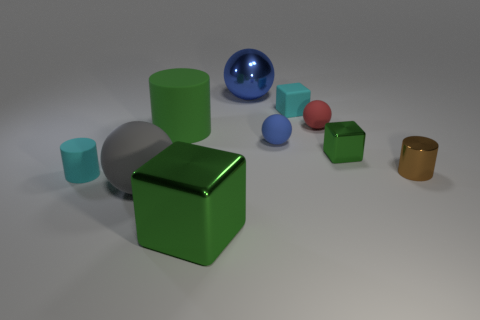What is the shape of the large metallic thing that is the same color as the big cylinder?
Provide a short and direct response. Cube. What size is the thing that is the same color as the tiny rubber block?
Offer a terse response. Small. Is there any other thing that has the same material as the tiny brown thing?
Keep it short and to the point. Yes. What is the shape of the tiny red thing?
Your answer should be compact. Sphere. What is the shape of the cyan object behind the tiny cylinder that is to the left of the red rubber thing?
Make the answer very short. Cube. Do the tiny thing in front of the brown cylinder and the tiny brown cylinder have the same material?
Ensure brevity in your answer.  No. What number of gray objects are either shiny cylinders or tiny cubes?
Your response must be concise. 0. Are there any rubber cylinders that have the same color as the matte block?
Make the answer very short. Yes. Are there any gray spheres made of the same material as the tiny blue ball?
Your answer should be very brief. Yes. What shape is the green thing that is in front of the large rubber cylinder and behind the big gray matte sphere?
Your answer should be compact. Cube. 